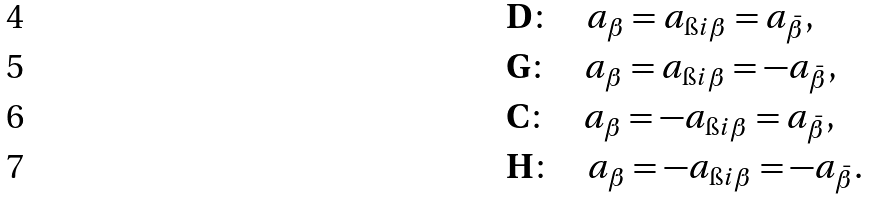<formula> <loc_0><loc_0><loc_500><loc_500>& { \mathbf D } \colon \quad a _ { \beta } = a _ { \i i \beta } = a _ { \bar { \beta } } , \\ & { \mathbf G } \colon \quad a _ { \beta } = a _ { \i i \beta } = - a _ { \bar { \beta } } , \\ & { \mathbf C } \colon \quad a _ { \beta } = - a _ { \i i \beta } = a _ { \bar { \beta } } , \\ & { \mathbf H } \colon \quad a _ { \beta } = - a _ { \i i \beta } = - a _ { \bar { \beta } } .</formula> 